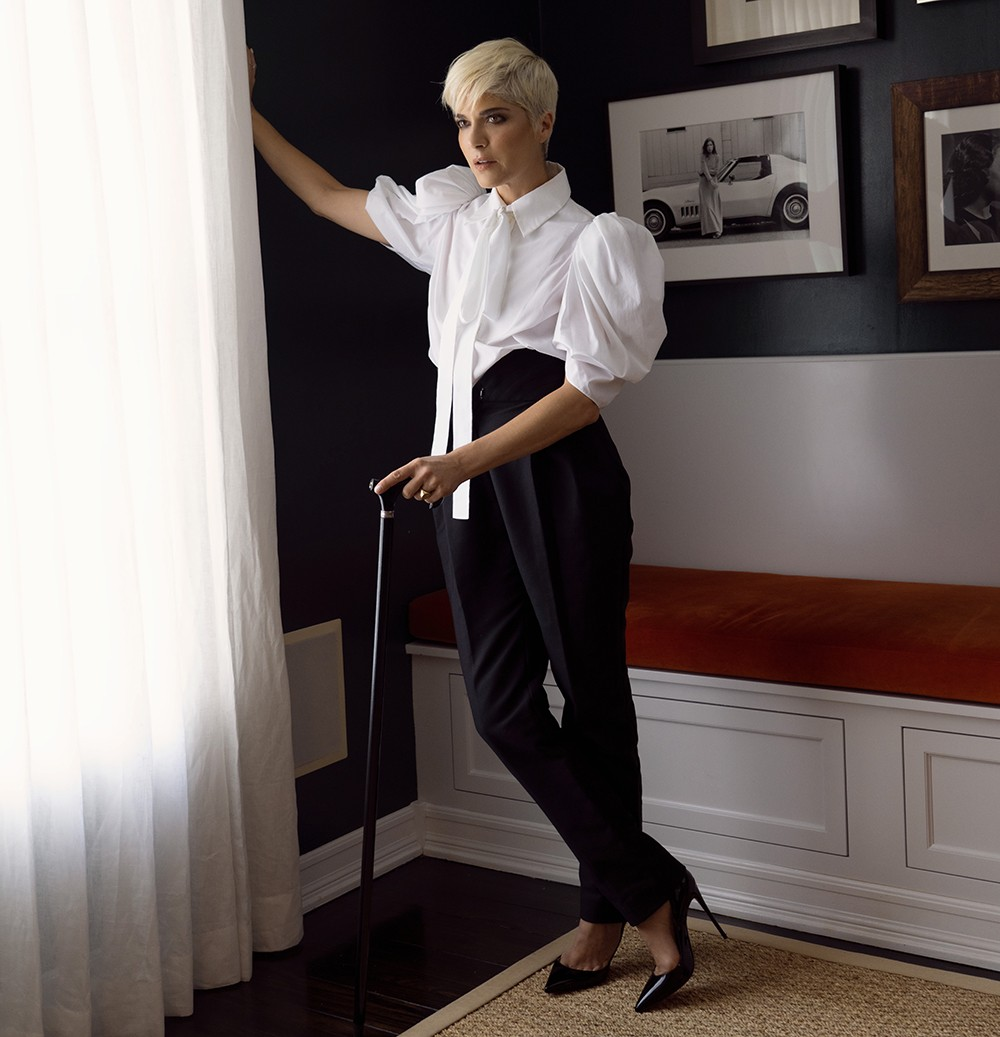Imagine this room could talk. What stories would it tell? If this room could talk, it would share tales of quiet introspection and resilience. It would tell of moments of solitude where deep thoughts and reflections unfolded in the stark contrast of black walls and white curtains. It would speak of challenges faced and overcome, symbolized by the cane held by the subject. The orange cushion on the bench would share stories of comfort and warmth, central to the room’s understated yet inviting elegance. The framed photos on the wall would reveal snippets of adventures and significant milestones, capturing the essence of life’s journey. 